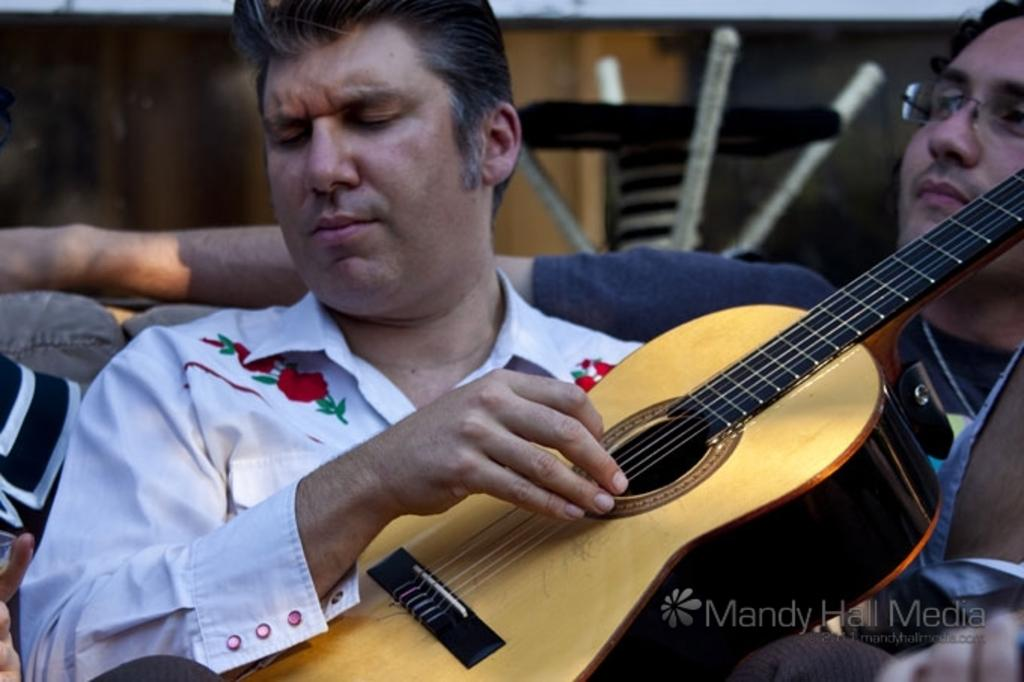What is the man in the image holding? The man is holding a guitar in the image. What is the man doing with the guitar? The man is playing the guitar. Can you describe the other person in the image? The second man is wearing spectacles. What can be seen in the background of the image? There is a wall in the background of the image. What type of rice is being served in the image? There is no rice visible in the image. Can you hear the bell ringing in the image? There is no bell in the image, so it cannot be heard. 